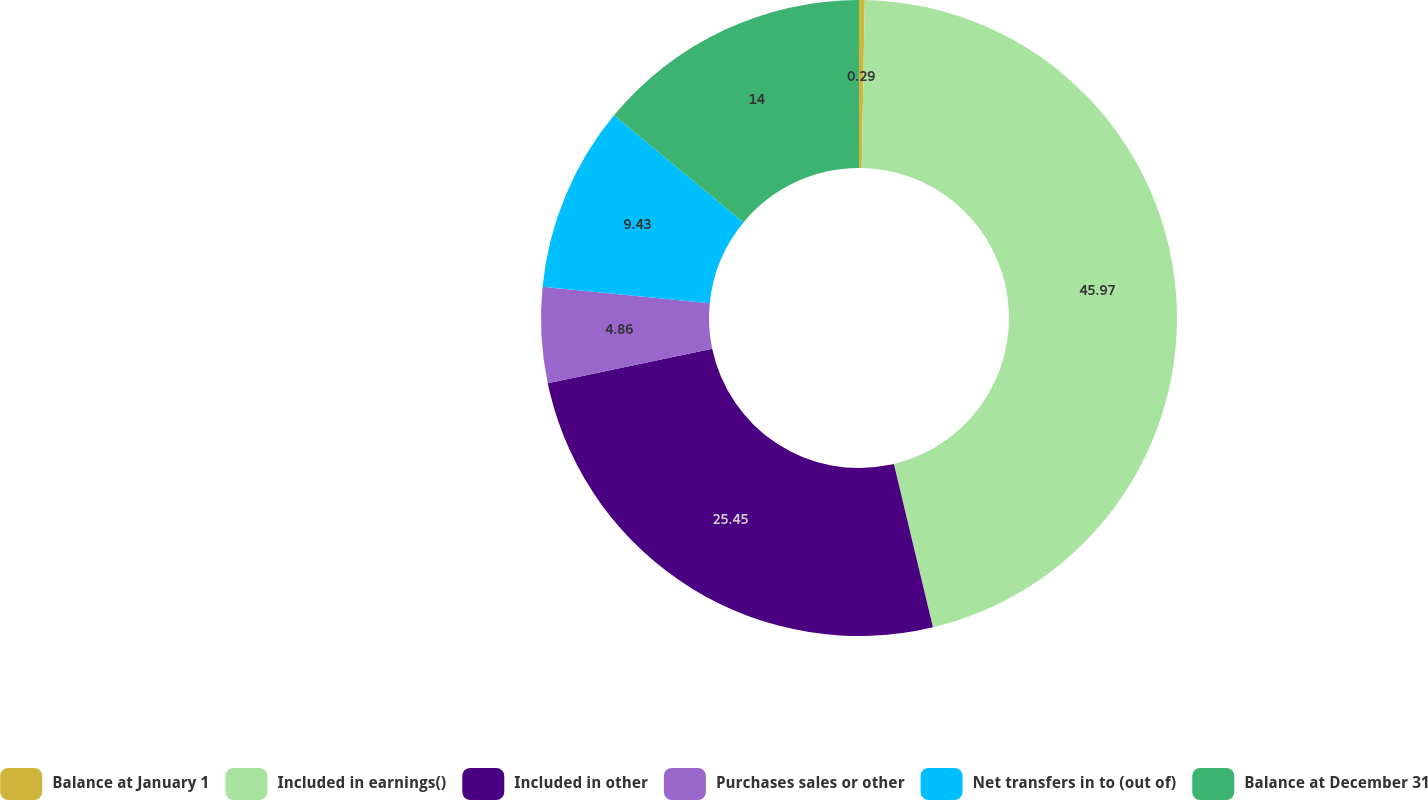Convert chart to OTSL. <chart><loc_0><loc_0><loc_500><loc_500><pie_chart><fcel>Balance at January 1<fcel>Included in earnings()<fcel>Included in other<fcel>Purchases sales or other<fcel>Net transfers in to (out of)<fcel>Balance at December 31<nl><fcel>0.29%<fcel>45.98%<fcel>25.45%<fcel>4.86%<fcel>9.43%<fcel>14.0%<nl></chart> 